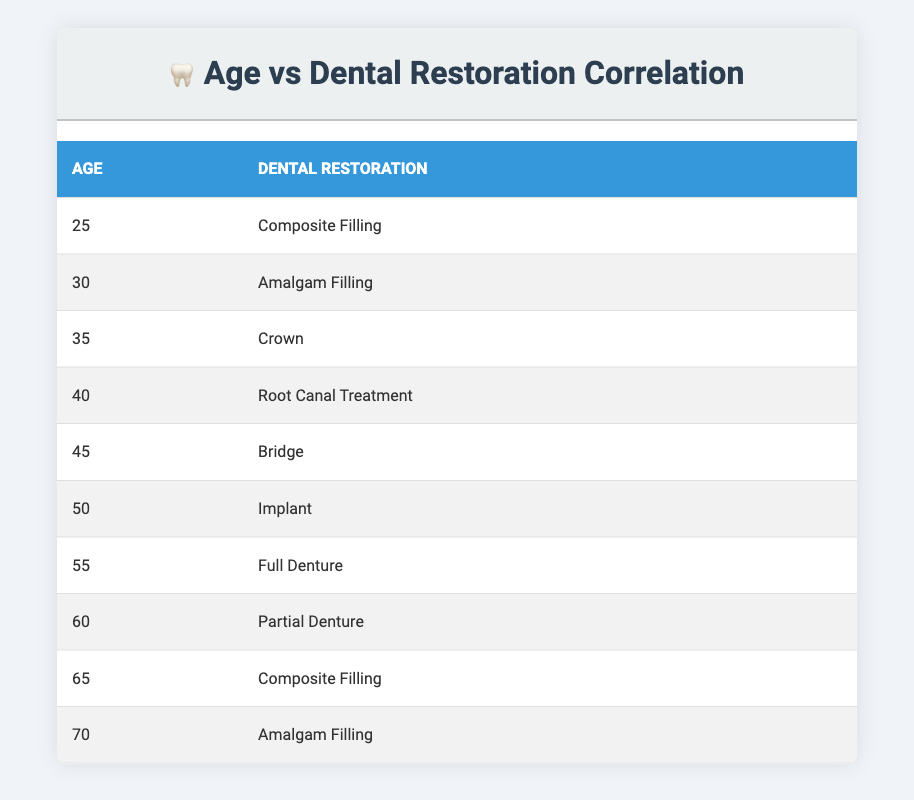What dental restoration is most common for individuals aged 25? In the table, the entry for age 25 shows a "Composite Filling" as the dental restoration type. This indicates that for individuals aged 25, this is the most common restoration listed.
Answer: Composite Filling How many individuals received a "Bridge" as a dental restoration? The table presents only one occurrence of a "Bridge" associated with an individual aged 45. Therefore, there is one individual who received this specific type of dental restoration.
Answer: 1 What is the age of individuals who received "Full Denture"? According to the table, the "Full Denture" is associated with the age of 55. This means that individuals at this age received the "Full Denture" restoration.
Answer: 55 What is the minimum age of individuals who received "Amalgam Filling"? The table lists "Amalgam Filling" for individuals aged 30 and 70. The minimum of these ages is 30. Thus, 30 is the minimum age associated with "Amalgam Filling".
Answer: 30 Is there any individual aged 60 receiving a "Crown"? The table shows that age 60 corresponds to a "Partial Denture," and age 35 corresponds to a "Crown." Since no individual aged 60 received a "Crown," the answer is no.
Answer: No What dental restoration types are received by individuals aged 40 to 60? For individuals aged 40 (Root Canal Treatment), 45 (Bridge), and 50 (Implant), there are 3 distinct restoration types listed. Thus, the restoration types for this age range are Root Canal Treatment, Bridge, and Implant.
Answer: 3 Which restoration type is associated with the oldest individual recorded, and what is that age? The oldest individual recorded in the table is 70 years old, and the associated restoration type is "Amalgam Filling." This indicates that the oldest individual received this treatment.
Answer: Amalgam Filling, 70 What is the average age of individuals receiving "Composite Filling"? Two individuals received "Composite Filling": one aged 25 and another aged 65. To find the average age, we sum these ages (25 + 65 = 90) and divide by the number of individuals (2). The average is therefore 90 / 2 = 45.
Answer: 45 How many different types of dental restorations are represented among individuals aged 50 and older? By examining the table, for individuals aged 50 (Implant), 55 (Full Denture), and 60 (Partial Denture), there are three distinct types of restorations. Thus, the total types of restorations among those aged 50 and older is three.
Answer: 3 